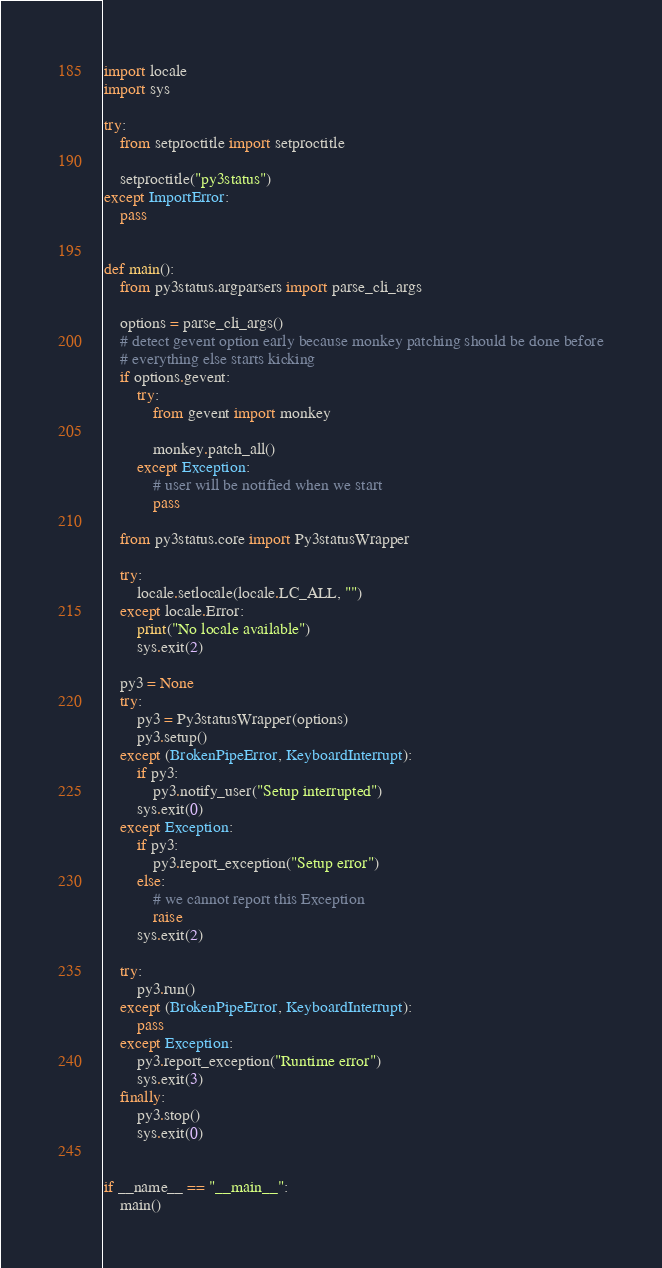<code> <loc_0><loc_0><loc_500><loc_500><_Python_>import locale
import sys

try:
    from setproctitle import setproctitle

    setproctitle("py3status")
except ImportError:
    pass


def main():
    from py3status.argparsers import parse_cli_args

    options = parse_cli_args()
    # detect gevent option early because monkey patching should be done before
    # everything else starts kicking
    if options.gevent:
        try:
            from gevent import monkey

            monkey.patch_all()
        except Exception:
            # user will be notified when we start
            pass

    from py3status.core import Py3statusWrapper

    try:
        locale.setlocale(locale.LC_ALL, "")
    except locale.Error:
        print("No locale available")
        sys.exit(2)

    py3 = None
    try:
        py3 = Py3statusWrapper(options)
        py3.setup()
    except (BrokenPipeError, KeyboardInterrupt):
        if py3:
            py3.notify_user("Setup interrupted")
        sys.exit(0)
    except Exception:
        if py3:
            py3.report_exception("Setup error")
        else:
            # we cannot report this Exception
            raise
        sys.exit(2)

    try:
        py3.run()
    except (BrokenPipeError, KeyboardInterrupt):
        pass
    except Exception:
        py3.report_exception("Runtime error")
        sys.exit(3)
    finally:
        py3.stop()
        sys.exit(0)


if __name__ == "__main__":
    main()
</code> 